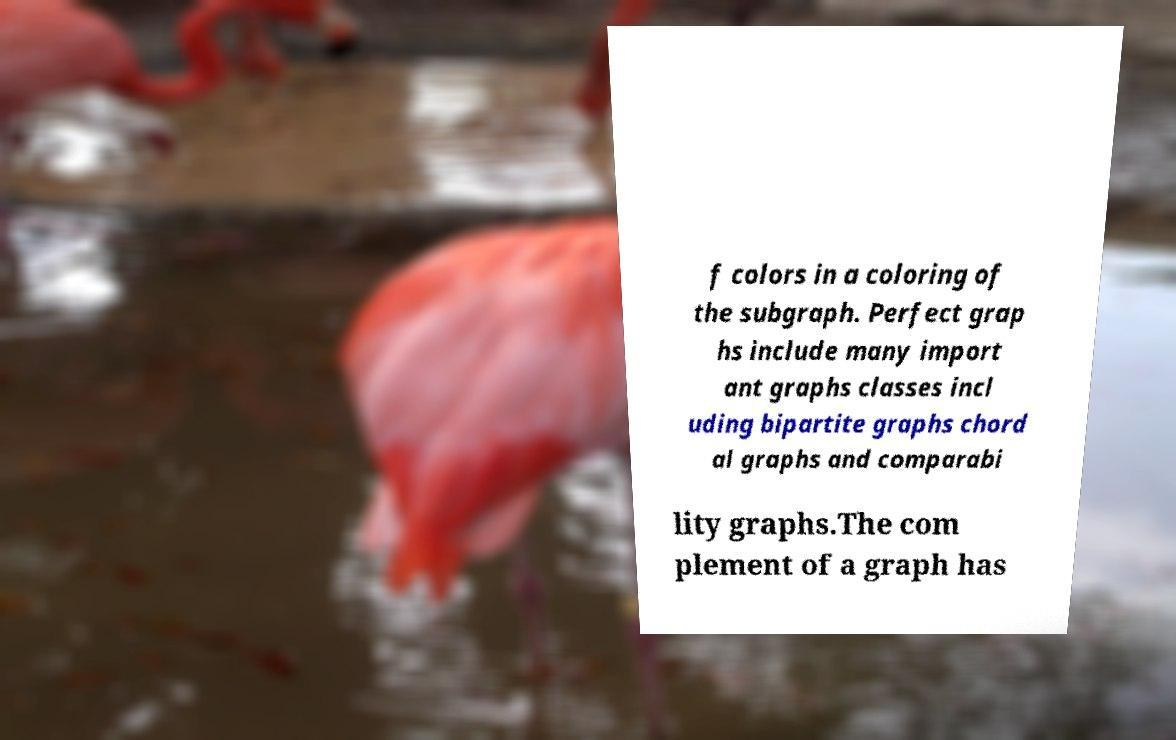I need the written content from this picture converted into text. Can you do that? f colors in a coloring of the subgraph. Perfect grap hs include many import ant graphs classes incl uding bipartite graphs chord al graphs and comparabi lity graphs.The com plement of a graph has 